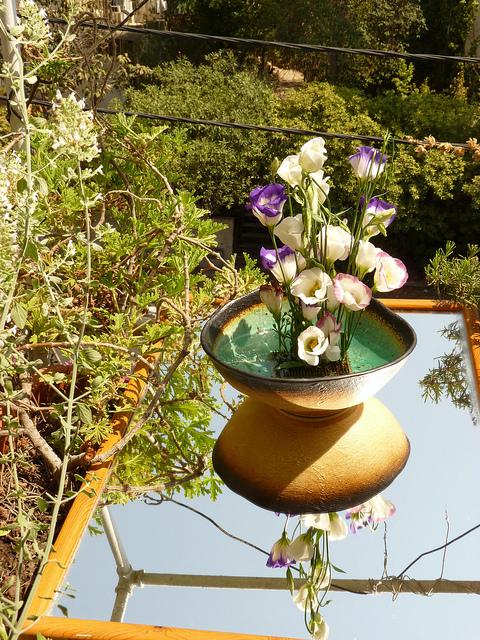How many flowers are in the vase?
Write a very short answer. 13. What kind of flowers are these?
Keep it brief. Tulip. What is the tabletop made from?
Answer briefly. Glass. Does the pot appear to be broken?
Concise answer only. No. 